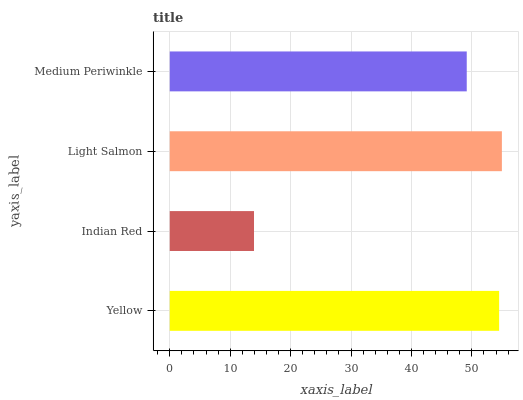Is Indian Red the minimum?
Answer yes or no. Yes. Is Light Salmon the maximum?
Answer yes or no. Yes. Is Light Salmon the minimum?
Answer yes or no. No. Is Indian Red the maximum?
Answer yes or no. No. Is Light Salmon greater than Indian Red?
Answer yes or no. Yes. Is Indian Red less than Light Salmon?
Answer yes or no. Yes. Is Indian Red greater than Light Salmon?
Answer yes or no. No. Is Light Salmon less than Indian Red?
Answer yes or no. No. Is Yellow the high median?
Answer yes or no. Yes. Is Medium Periwinkle the low median?
Answer yes or no. Yes. Is Light Salmon the high median?
Answer yes or no. No. Is Light Salmon the low median?
Answer yes or no. No. 